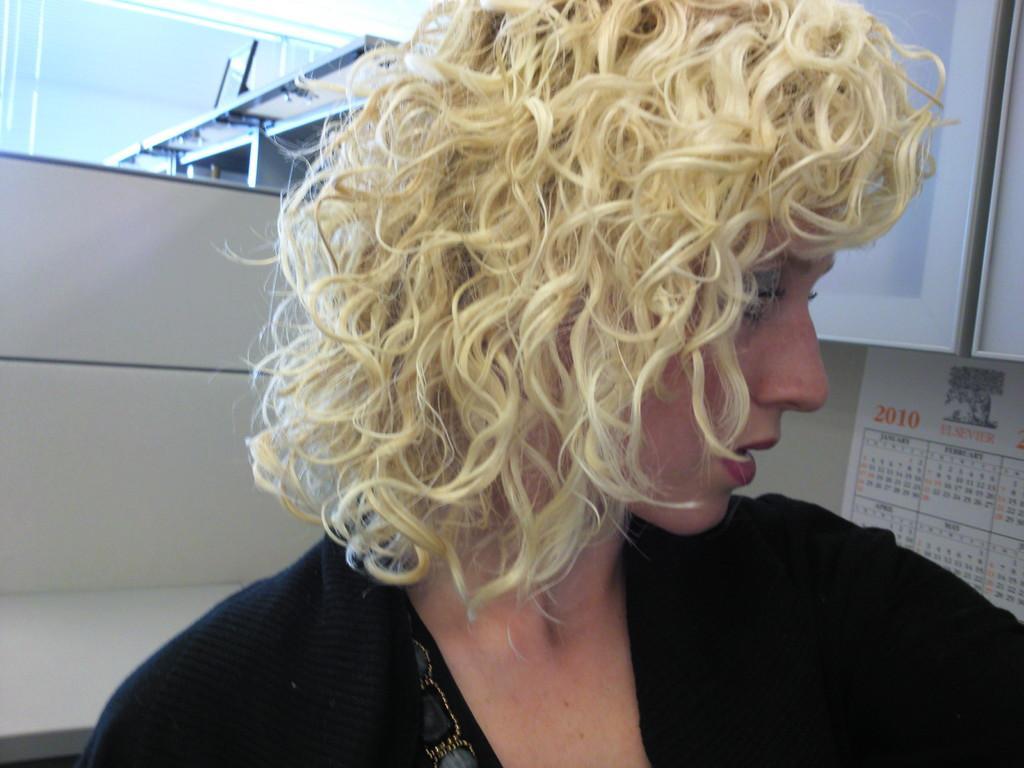How would you summarize this image in a sentence or two? In this image there is a woman , she wearing black color dress, in the background there is a wall to that wall there is a calendar. 